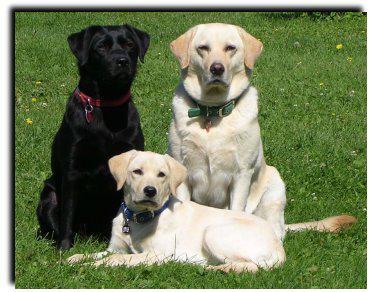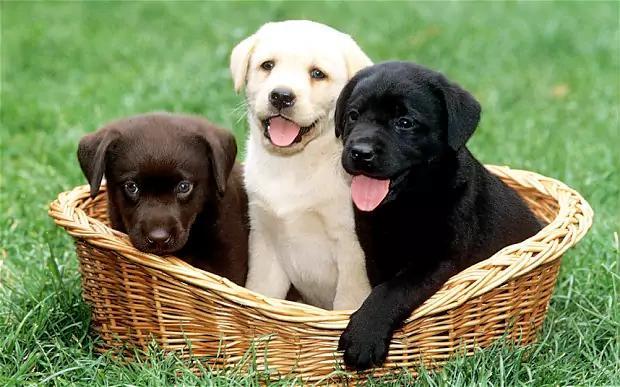The first image is the image on the left, the second image is the image on the right. For the images shown, is this caption "The left image includes a royal blue leash and an adult white dog sitting upright on green grass." true? Answer yes or no. No. The first image is the image on the left, the second image is the image on the right. Evaluate the accuracy of this statement regarding the images: "There is at least one dog wearing a leash". Is it true? Answer yes or no. No. 